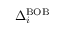<formula> <loc_0><loc_0><loc_500><loc_500>\Delta _ { i } ^ { B O B }</formula> 